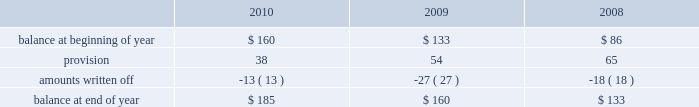Allowance for doubtful accounts is as follows: .
Discontinued operations during the fourth quarter of 2009 , schlumberger recorded a net $ 22 million charge related to the resolution of a customs assessment pertaining to its former offshore contract drilling business , as well as the resolution of certain contingencies associated with other previously disposed of businesses .
This amount is included in income ( loss ) from discontinued operations in the consolidated statement of income .
During the first quarter of 2008 , schlumberger recorded a gain of $ 38 million related to the resolution of a contingency associated with a previously disposed of business .
This gain is included in income ( loss ) from discon- tinued operations in the consolidated statement of income .
Part ii , item 8 .
What was the percentage increase in the allowance in doubtful accounts from 2009 to 2010? 
Rationale: the percentage change is the recent amount less the prior amount divide by the prior amount
Computations: ((185 - 160) / 160)
Answer: 0.15625. 